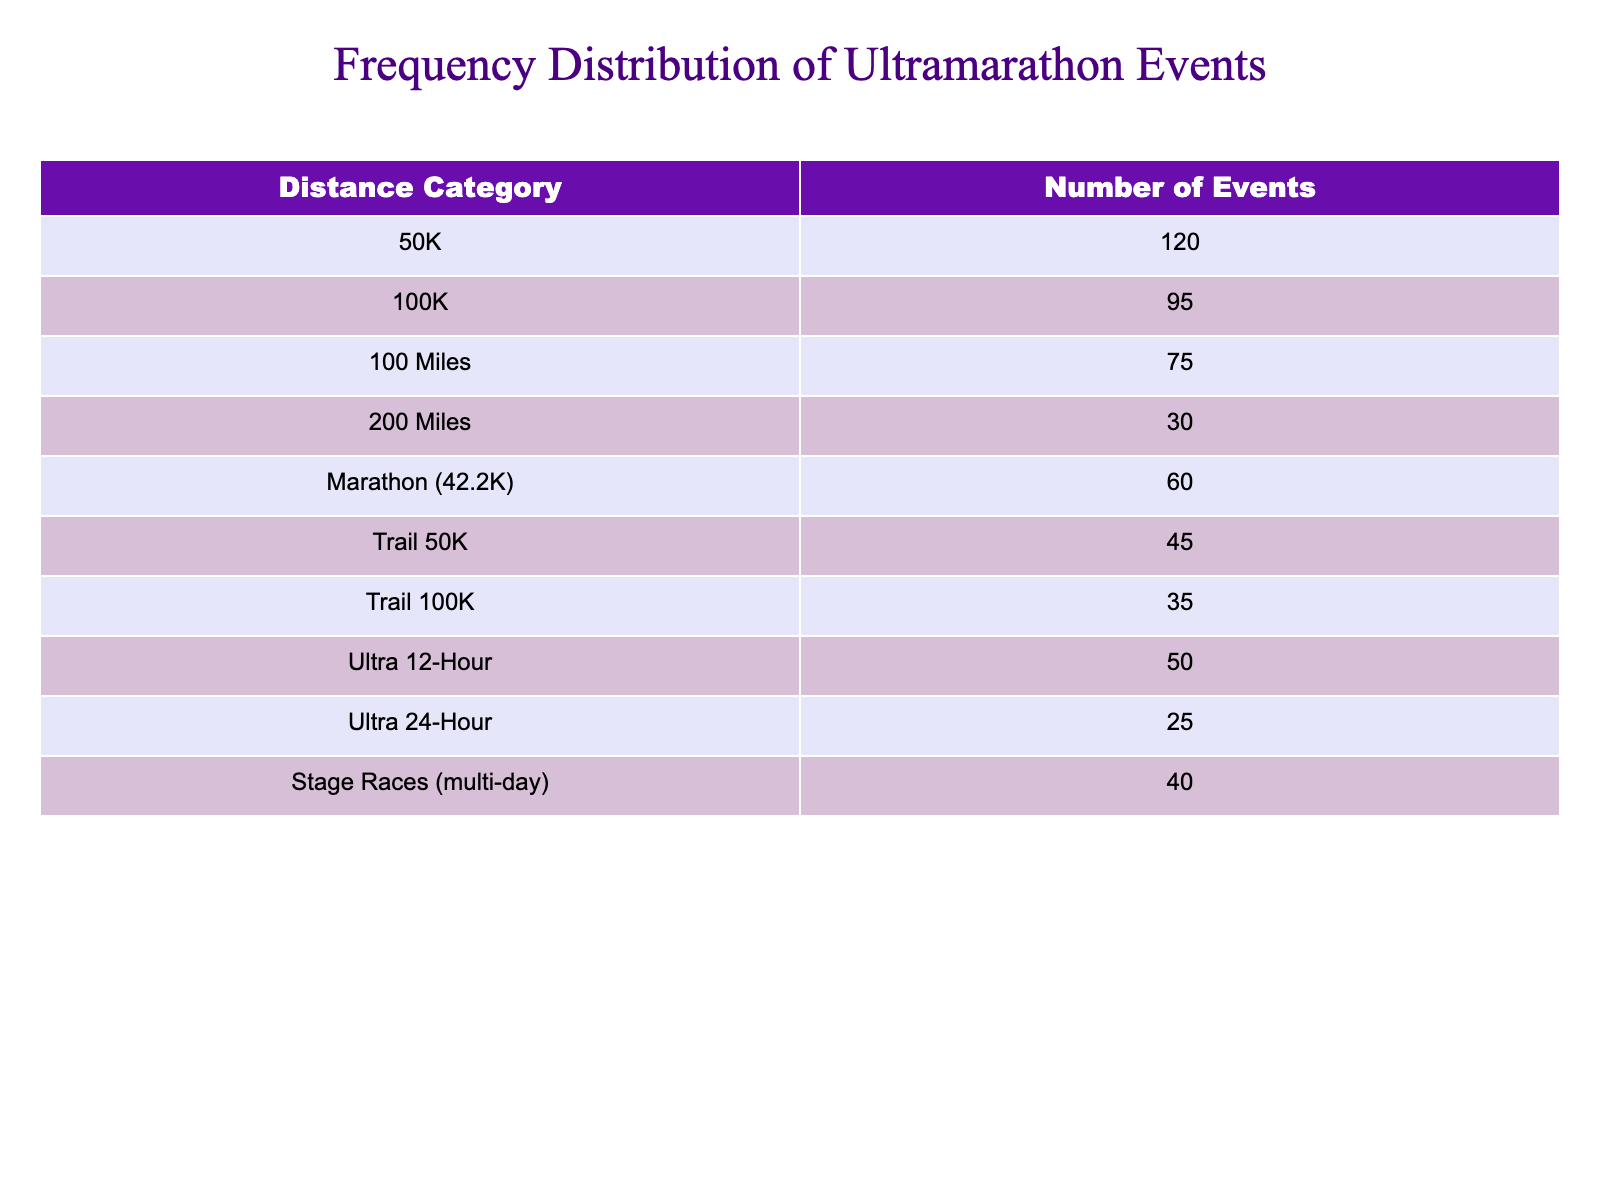What is the total number of 100-mile events? The table shows there are 75 events listed under the "100 Miles" distance category.
Answer: 75 Which distance category has the highest number of events? By comparing the numbers in each category, 50K has the highest number at 120 events.
Answer: 50K How many more 50K events are there than Trail 100K events? The number of 50K events is 120, while Trail 100K has 35 events. The difference is 120 - 35 = 85.
Answer: 85 Is the number of Ultra 24-Hour events greater than Trail 50K events? There are 25 Ultra 24-Hour events and 45 Trail 50K events. Since 25 is less than 45, the statement is false.
Answer: No What is the average number of events across the Ultra distance categories (Ultra 12-Hour and Ultra 24-Hour)? The Ultra distance categories have 50 Ultra 12-Hour events and 25 Ultra 24-Hour events. To find the average, add 50 + 25 = 75, then divide by 2, giving 75 / 2 = 37.5.
Answer: 37.5 If we combine the number of 100K and 100-mile events, what is the total? The 100K events total 95 and the 100-mile events total 75. Adding these gives 95 + 75 = 170.
Answer: 170 How many events are in the Trail distance categories combined? Trail 50K has 45 events and Trail 100K has 35 events. To find the total, sum these up: 45 + 35 = 80.
Answer: 80 Which event category has the least number of events? By examining the numbers in the table, the "Ultra 24-Hour" category has the least with 25 events.
Answer: Ultra 24-Hour Are there more 200-mile events than Marathon events? The table shows there are 30 events for 200 miles and 60 for Marathon. Since 30 is less than 60, the statement is false.
Answer: No 